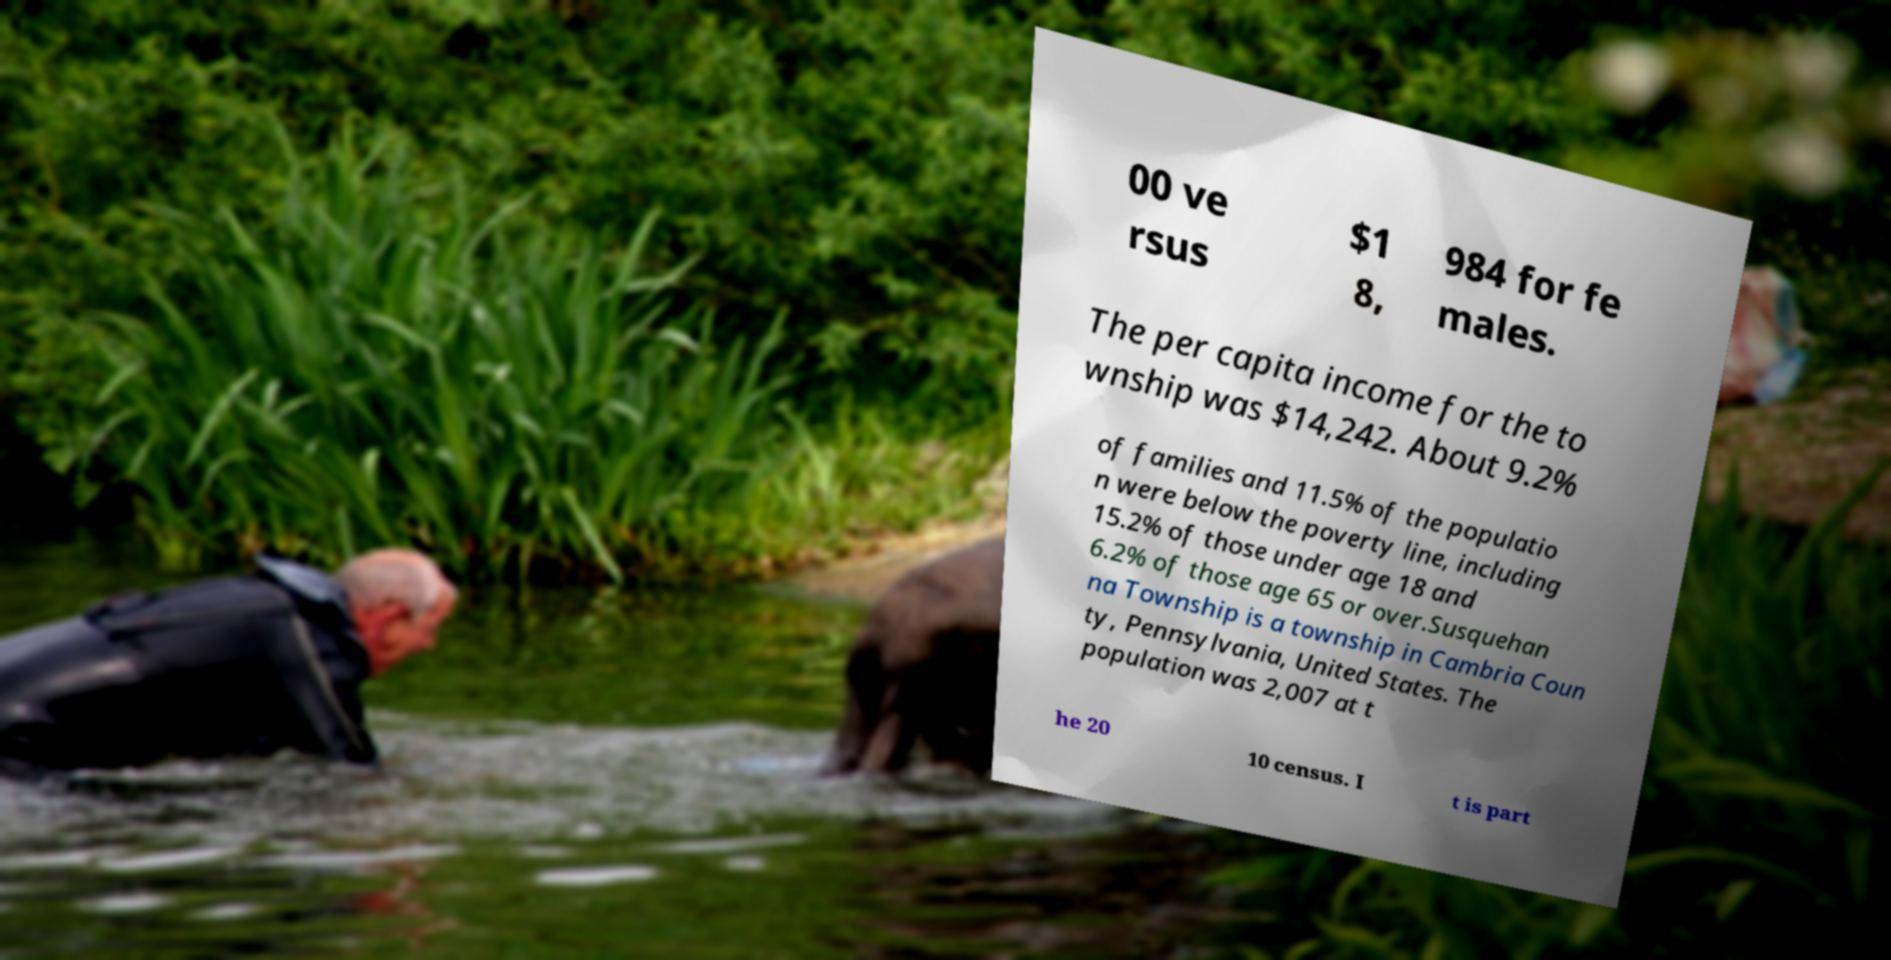Can you accurately transcribe the text from the provided image for me? 00 ve rsus $1 8, 984 for fe males. The per capita income for the to wnship was $14,242. About 9.2% of families and 11.5% of the populatio n were below the poverty line, including 15.2% of those under age 18 and 6.2% of those age 65 or over.Susquehan na Township is a township in Cambria Coun ty, Pennsylvania, United States. The population was 2,007 at t he 20 10 census. I t is part 